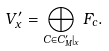<formula> <loc_0><loc_0><loc_500><loc_500>V ^ { \prime } _ { x } = \bigoplus _ { C \in C ^ { \prime } _ { M } | _ { x } } F _ { c } .</formula> 